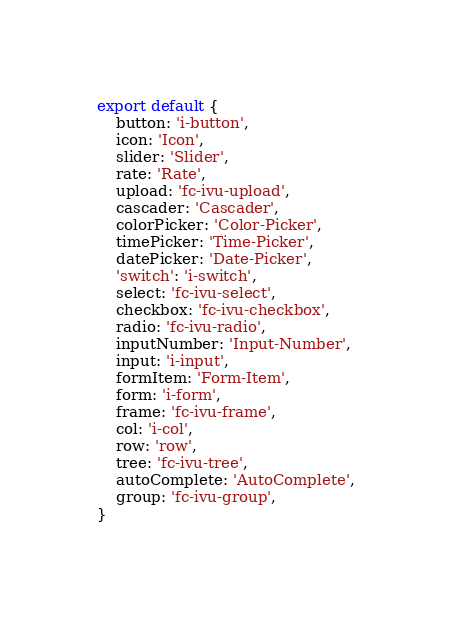<code> <loc_0><loc_0><loc_500><loc_500><_JavaScript_>export default {
    button: 'i-button',
    icon: 'Icon',
    slider: 'Slider',
    rate: 'Rate',
    upload: 'fc-ivu-upload',
    cascader: 'Cascader',
    colorPicker: 'Color-Picker',
    timePicker: 'Time-Picker',
    datePicker: 'Date-Picker',
    'switch': 'i-switch',
    select: 'fc-ivu-select',
    checkbox: 'fc-ivu-checkbox',
    radio: 'fc-ivu-radio',
    inputNumber: 'Input-Number',
    input: 'i-input',
    formItem: 'Form-Item',
    form: 'i-form',
    frame: 'fc-ivu-frame',
    col: 'i-col',
    row: 'row',
    tree: 'fc-ivu-tree',
    autoComplete: 'AutoComplete',
    group: 'fc-ivu-group',
}
</code> 